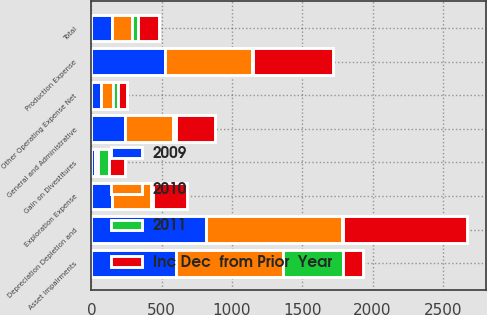Convert chart to OTSL. <chart><loc_0><loc_0><loc_500><loc_500><stacked_bar_chart><ecel><fcel>Production Expense<fcel>Exploration Expense<fcel>Depreciation Depletion and<fcel>General and Administrative<fcel>Gain on Divestitures<fcel>Asset Impairments<fcel>Other Operating Expense Net<fcel>Total<nl><fcel>2010<fcel>618<fcel>279<fcel>965<fcel>341<fcel>25<fcel>759<fcel>86<fcel>144<nl><fcel>2011<fcel>8<fcel>14<fcel>9<fcel>23<fcel>78<fcel>427<fcel>34<fcel>46<nl><fcel>Inc Dec  from Prior  Year<fcel>570<fcel>245<fcel>883<fcel>277<fcel>113<fcel>144<fcel>64<fcel>144<nl><fcel>2009<fcel>525<fcel>144<fcel>816<fcel>237<fcel>22<fcel>604<fcel>67<fcel>144<nl></chart> 